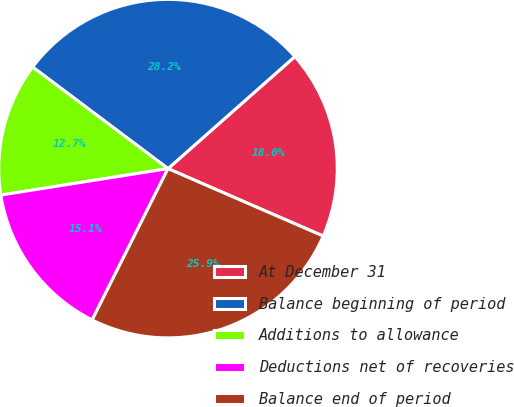Convert chart to OTSL. <chart><loc_0><loc_0><loc_500><loc_500><pie_chart><fcel>At December 31<fcel>Balance beginning of period<fcel>Additions to allowance<fcel>Deductions net of recoveries<fcel>Balance end of period<nl><fcel>18.04%<fcel>28.24%<fcel>12.74%<fcel>15.11%<fcel>25.87%<nl></chart> 